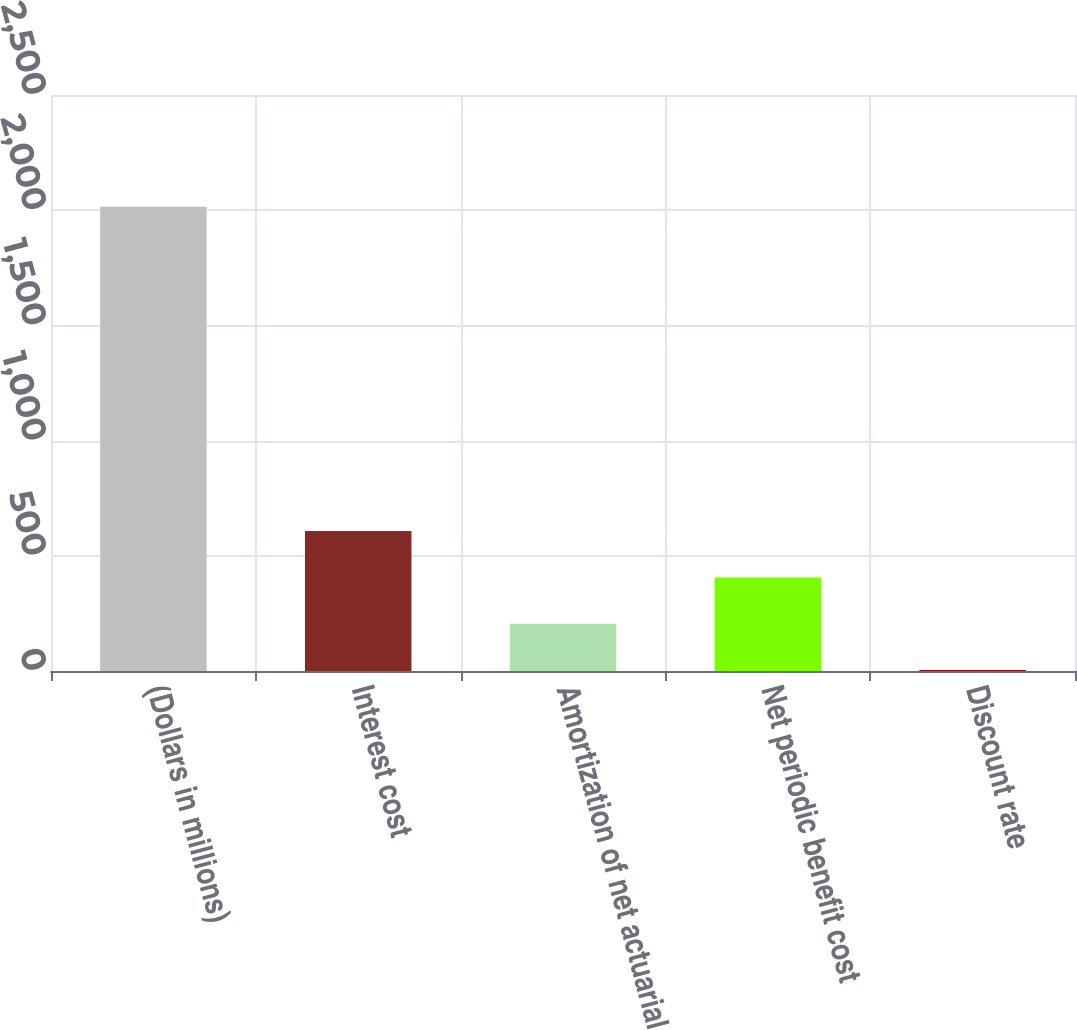Convert chart. <chart><loc_0><loc_0><loc_500><loc_500><bar_chart><fcel>(Dollars in millions)<fcel>Interest cost<fcel>Amortization of net actuarial<fcel>Net periodic benefit cost<fcel>Discount rate<nl><fcel>2015<fcel>607.16<fcel>204.92<fcel>406.04<fcel>3.8<nl></chart> 